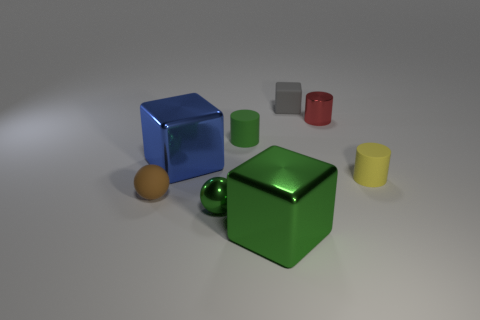What size is the rubber cylinder that is the same color as the small metal sphere?
Provide a succinct answer. Small. What number of big things are there?
Your response must be concise. 2. How many cyan rubber cubes are the same size as the yellow thing?
Your response must be concise. 0. What is the green cube made of?
Your answer should be very brief. Metal. Do the small matte cube and the small object in front of the small brown thing have the same color?
Ensure brevity in your answer.  No. There is a matte thing that is in front of the blue metal block and to the right of the big blue object; what size is it?
Your answer should be very brief. Small. What shape is the small yellow thing that is made of the same material as the small cube?
Your answer should be compact. Cylinder. Is the material of the small block the same as the big block behind the small brown ball?
Offer a terse response. No. Is there a big blue metal object that is in front of the tiny ball that is right of the tiny rubber ball?
Ensure brevity in your answer.  No. What is the material of the other large thing that is the same shape as the blue object?
Your answer should be compact. Metal. 